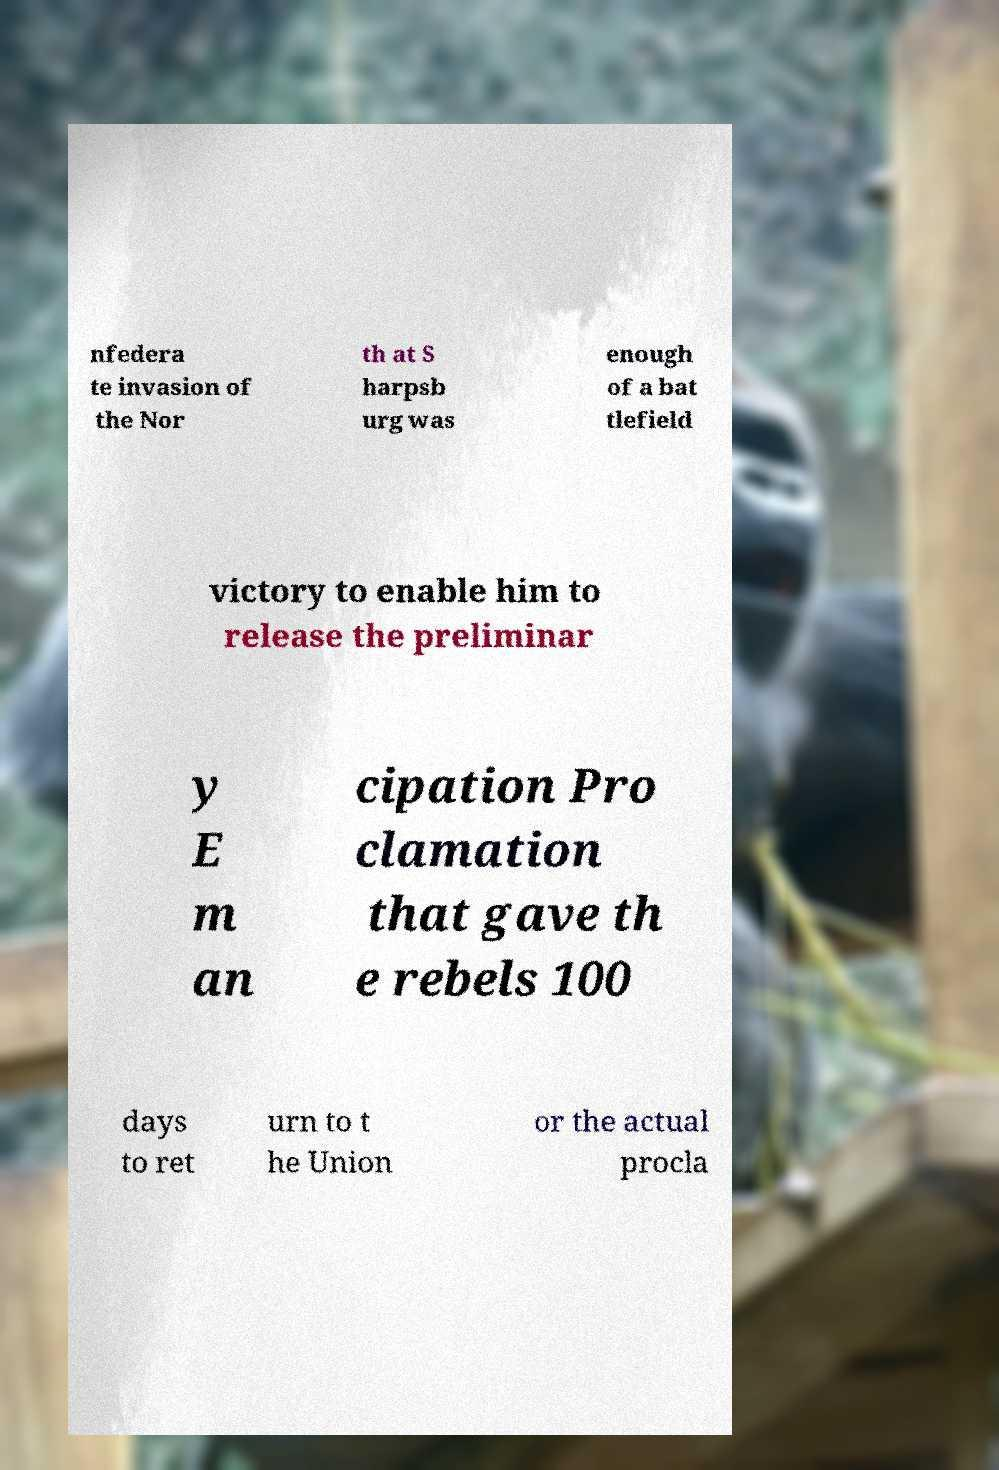Please read and relay the text visible in this image. What does it say? nfedera te invasion of the Nor th at S harpsb urg was enough of a bat tlefield victory to enable him to release the preliminar y E m an cipation Pro clamation that gave th e rebels 100 days to ret urn to t he Union or the actual procla 